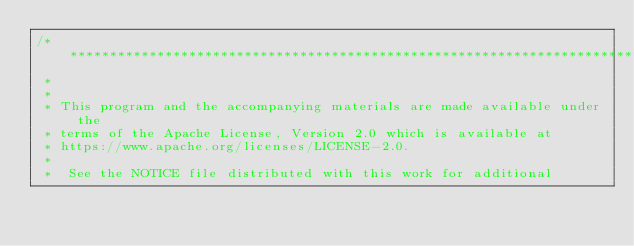Convert code to text. <code><loc_0><loc_0><loc_500><loc_500><_Cuda_>/* ******************************************************************************
 *
 *
 * This program and the accompanying materials are made available under the
 * terms of the Apache License, Version 2.0 which is available at
 * https://www.apache.org/licenses/LICENSE-2.0.
 *
 *  See the NOTICE file distributed with this work for additional</code> 